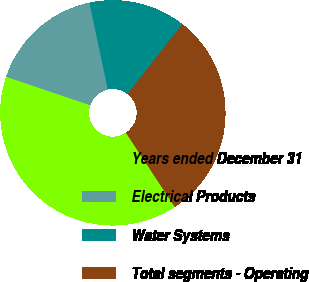Convert chart to OTSL. <chart><loc_0><loc_0><loc_500><loc_500><pie_chart><fcel>Years ended December 31<fcel>Electrical Products<fcel>Water Systems<fcel>Total segments - Operating<nl><fcel>39.46%<fcel>16.47%<fcel>13.91%<fcel>30.16%<nl></chart> 